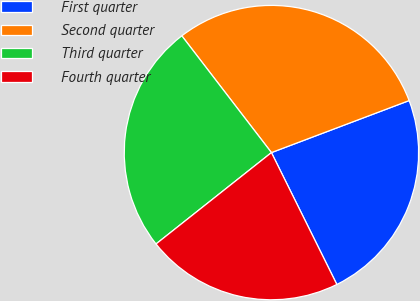<chart> <loc_0><loc_0><loc_500><loc_500><pie_chart><fcel>First quarter<fcel>Second quarter<fcel>Third quarter<fcel>Fourth quarter<nl><fcel>23.42%<fcel>29.67%<fcel>25.24%<fcel>21.67%<nl></chart> 